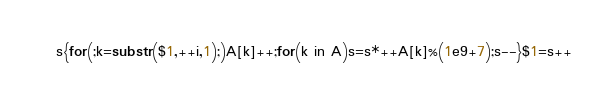Convert code to text. <code><loc_0><loc_0><loc_500><loc_500><_Awk_>s{for(;k=substr($1,++i,1);)A[k]++;for(k in A)s=s*++A[k]%(1e9+7);s--}$1=s++</code> 